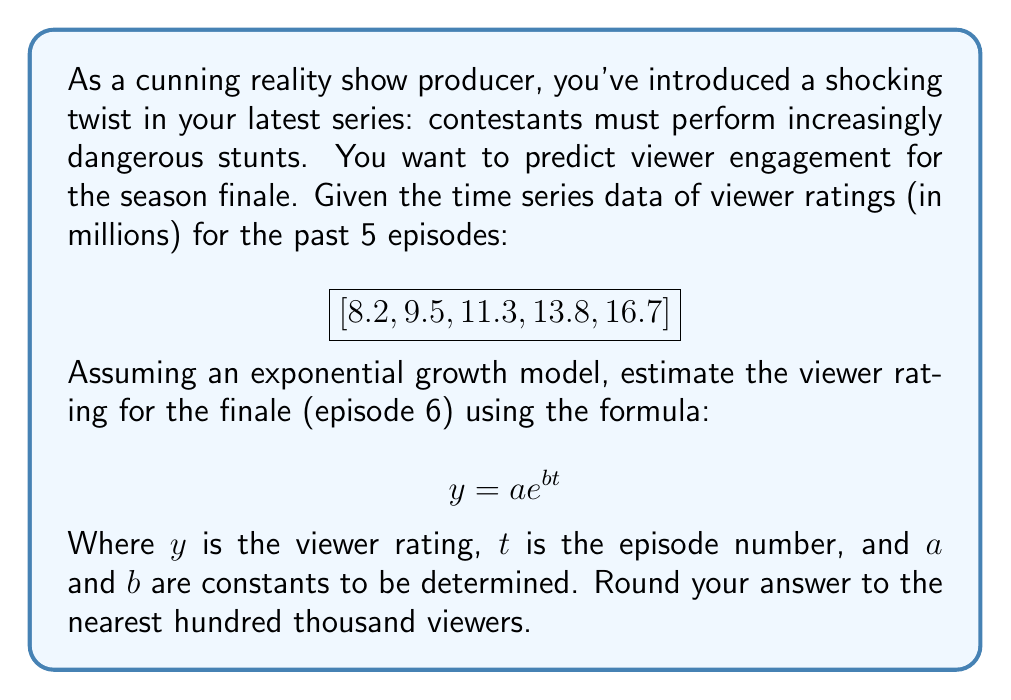Teach me how to tackle this problem. To solve this problem, we'll use the exponential growth model and logarithmic regression:

1) First, let's transform the data by taking the natural logarithm of y:

   $\ln(y) = \ln(a) + bt$

2) Create a table with $t$ and $\ln(y)$:

   $t: [1, 2, 3, 4, 5]$
   $\ln(y): [2.104, 2.251, 2.425, 2.625, 2.815]$

3) Use linear regression to find the slope (b) and y-intercept $(\ln(a))$:

   $b = \frac{n\sum(t\ln(y)) - \sum t \sum \ln(y)}{n\sum t^2 - (\sum t)^2}$

   $\ln(a) = \frac{\sum \ln(y)}{n} - b\frac{\sum t}{n}$

4) Calculating:
   
   $b = 0.1785$
   $\ln(a) = 1.9255$

5) Therefore, $a = e^{1.9255} = 6.8589$

6) Our model is: $y = 6.8589e^{0.1785t}$

7) For the finale (episode 6):

   $y = 6.8589e^{0.1785(6)} = 20.3827$ million viewers

8) Rounding to the nearest hundred thousand:

   20.4 million viewers
Answer: 20.4 million viewers 